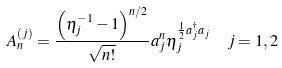Convert formula to latex. <formula><loc_0><loc_0><loc_500><loc_500>A _ { n } ^ { ( j ) } & = \frac { \left ( { \eta _ { j } ^ { - 1 } - 1 } \right ) ^ { n / 2 } } { \sqrt { n ! } } a _ { j } ^ { n } \eta _ { j } ^ { \frac { 1 } { 2 } a _ { j } ^ { \dag } a _ { j } } \quad j = 1 , 2</formula> 